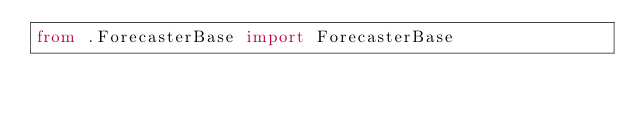Convert code to text. <code><loc_0><loc_0><loc_500><loc_500><_Python_>from .ForecasterBase import ForecasterBase</code> 